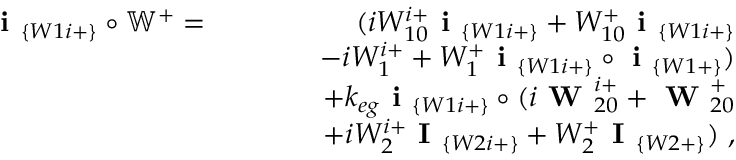<formula> <loc_0><loc_0><loc_500><loc_500>\begin{array} { r l r } { i _ { \{ W 1 i + \} } \circ \mathbb { W } ^ { + } = } & { ( i W _ { 1 0 } ^ { i + } i _ { \{ W 1 i + \} } + W _ { 1 0 } ^ { + } i _ { \{ W 1 i + \} } } \\ & { - i W _ { 1 } ^ { i + } + W _ { 1 } ^ { + } i _ { \{ W 1 i + \} } \circ i _ { \{ W 1 + \} } ) } \\ & { + k _ { e g } i _ { \{ W 1 i + \} } \circ ( i W _ { 2 0 } ^ { i + } + W _ { 2 0 } ^ { + } } \\ & { + i W _ { 2 } ^ { i + } I _ { \{ W 2 i + \} } + W _ { 2 } ^ { + } I _ { \{ W 2 + \} } ) , } \end{array}</formula> 